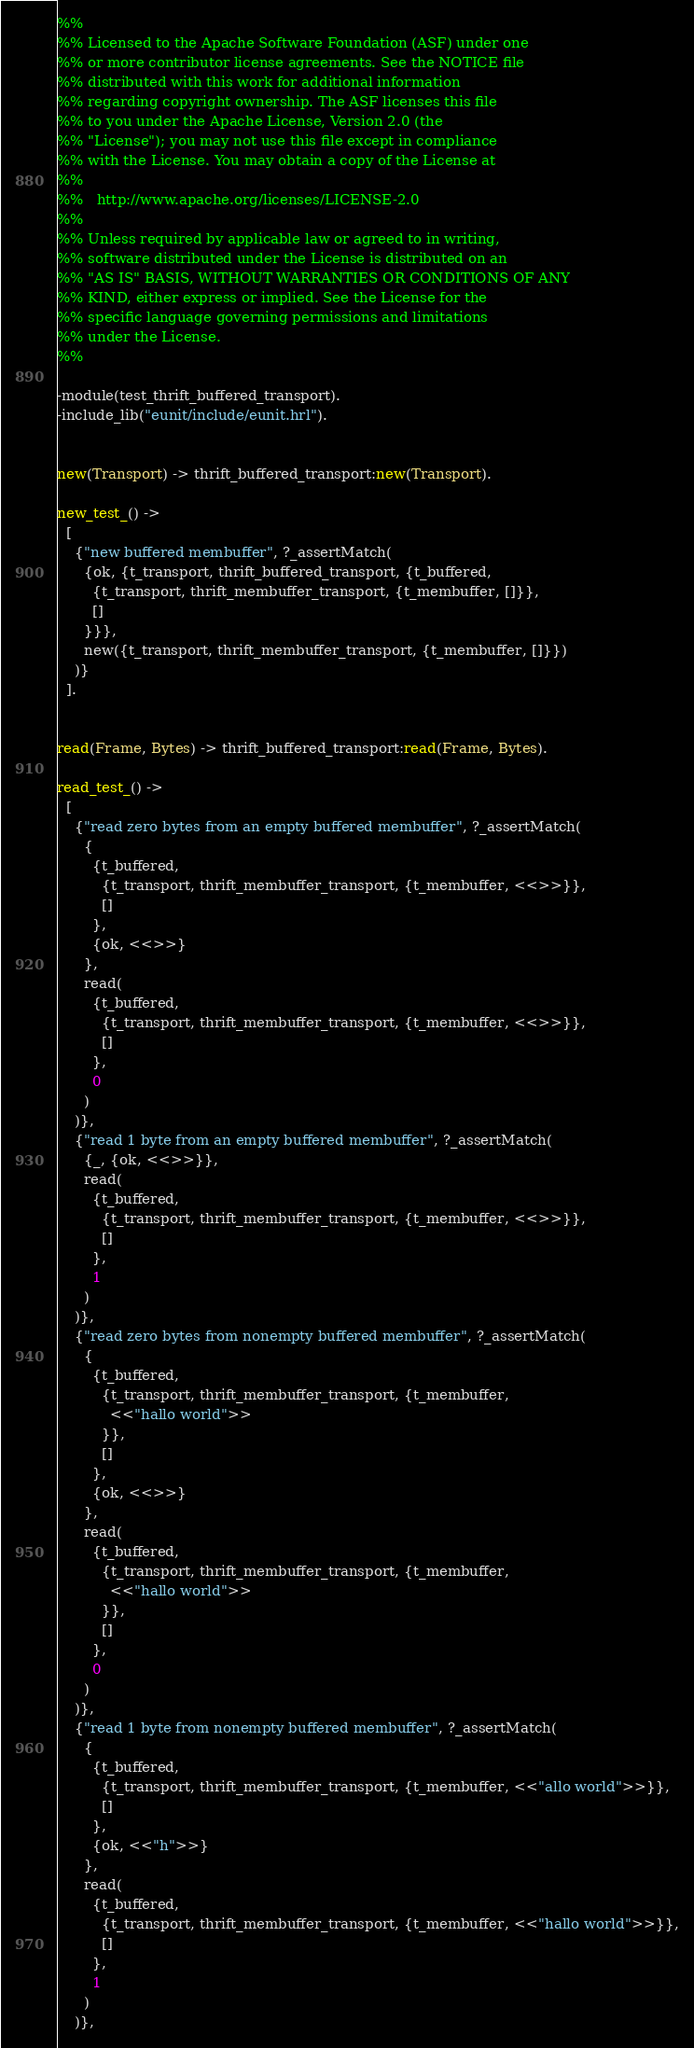<code> <loc_0><loc_0><loc_500><loc_500><_Erlang_>%%
%% Licensed to the Apache Software Foundation (ASF) under one
%% or more contributor license agreements. See the NOTICE file
%% distributed with this work for additional information
%% regarding copyright ownership. The ASF licenses this file
%% to you under the Apache License, Version 2.0 (the
%% "License"); you may not use this file except in compliance
%% with the License. You may obtain a copy of the License at
%%
%%   http://www.apache.org/licenses/LICENSE-2.0
%%
%% Unless required by applicable law or agreed to in writing,
%% software distributed under the License is distributed on an
%% "AS IS" BASIS, WITHOUT WARRANTIES OR CONDITIONS OF ANY
%% KIND, either express or implied. See the License for the
%% specific language governing permissions and limitations
%% under the License.
%%

-module(test_thrift_buffered_transport).
-include_lib("eunit/include/eunit.hrl").


new(Transport) -> thrift_buffered_transport:new(Transport).

new_test_() ->
  [
    {"new buffered membuffer", ?_assertMatch(
      {ok, {t_transport, thrift_buffered_transport, {t_buffered,
        {t_transport, thrift_membuffer_transport, {t_membuffer, []}},
        []
      }}},
      new({t_transport, thrift_membuffer_transport, {t_membuffer, []}})
    )}
  ].


read(Frame, Bytes) -> thrift_buffered_transport:read(Frame, Bytes).

read_test_() ->
  [
    {"read zero bytes from an empty buffered membuffer", ?_assertMatch(
      {
        {t_buffered,
          {t_transport, thrift_membuffer_transport, {t_membuffer, <<>>}},
          []
        },
        {ok, <<>>}
      },
      read(
        {t_buffered,
          {t_transport, thrift_membuffer_transport, {t_membuffer, <<>>}},
          []
        },
        0
      )
    )},
    {"read 1 byte from an empty buffered membuffer", ?_assertMatch(
      {_, {ok, <<>>}},
      read(
        {t_buffered,
          {t_transport, thrift_membuffer_transport, {t_membuffer, <<>>}},
          []
        },
        1
      )
    )},
    {"read zero bytes from nonempty buffered membuffer", ?_assertMatch(
      {
        {t_buffered,
          {t_transport, thrift_membuffer_transport, {t_membuffer,
            <<"hallo world">>
          }},
          []
        },
        {ok, <<>>}
      },
      read(
        {t_buffered,
          {t_transport, thrift_membuffer_transport, {t_membuffer,
            <<"hallo world">>
          }},
          []
        },
        0
      )
    )},
    {"read 1 byte from nonempty buffered membuffer", ?_assertMatch(
      {
        {t_buffered,
          {t_transport, thrift_membuffer_transport, {t_membuffer, <<"allo world">>}},
          []
        },
        {ok, <<"h">>}
      },
      read(
        {t_buffered,
          {t_transport, thrift_membuffer_transport, {t_membuffer, <<"hallo world">>}},
          []
        },
        1
      )
    )},</code> 